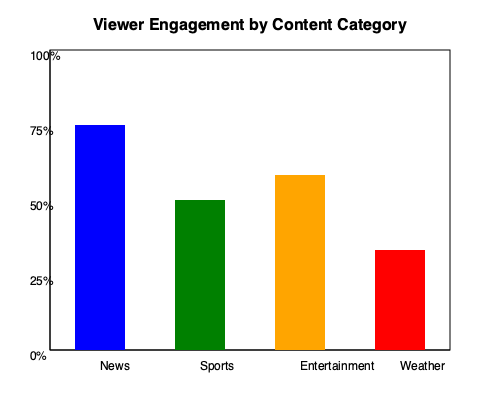Based on the bar graph showing viewer engagement by content category, which category has the highest engagement rate, and what percentage of viewers does it engage? To answer this question, we need to follow these steps:

1. Identify the categories: The graph shows four categories - News, Sports, Entertainment, and Weather.

2. Compare the heights of the bars: The height of each bar represents the engagement rate for that category.
   - News (blue bar): Extends from 25% to 100% on the y-axis
   - Sports (green bar): Extends from 50% to 100% on the y-axis
   - Entertainment (orange bar): Extends from about 42% to 100% on the y-axis
   - Weather (red bar): Extends from 75% to 100% on the y-axis

3. Determine the highest bar: The blue bar representing News is the tallest, reaching the 100% mark.

4. Calculate the engagement rate: The News bar starts at the 25% mark and reaches 100%.
   Engagement rate = 100% - 25% = 75%

Therefore, the News category has the highest engagement rate at 75%.
Answer: News, 75% 